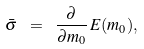Convert formula to latex. <formula><loc_0><loc_0><loc_500><loc_500>\bar { \sigma } \ = \ \frac { \partial } { \partial m _ { 0 } } \, E ( m _ { 0 } ) ,</formula> 